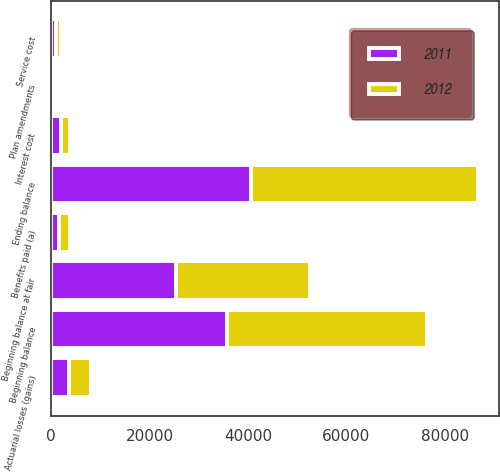Convert chart to OTSL. <chart><loc_0><loc_0><loc_500><loc_500><stacked_bar_chart><ecel><fcel>Beginning balance<fcel>Service cost<fcel>Interest cost<fcel>Benefits paid (a)<fcel>Actuarial losses (gains)<fcel>Plan amendments<fcel>Ending balance<fcel>Beginning balance at fair<nl><fcel>2012<fcel>40616<fcel>1055<fcel>1884<fcel>2094<fcel>4442<fcel>114<fcel>46017<fcel>27292<nl><fcel>2011<fcel>35773<fcel>974<fcel>1918<fcel>1685<fcel>3632<fcel>4<fcel>40616<fcel>25345<nl></chart> 